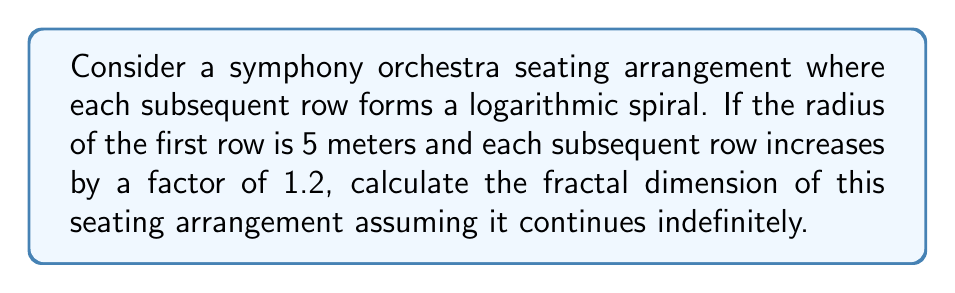Could you help me with this problem? To calculate the fractal dimension of this orchestral seating arrangement, we'll use the box-counting method. Let's approach this step-by-step:

1) In a logarithmic spiral, the distance from the center increases exponentially with each turn. The radius $r$ at angle $\theta$ is given by:

   $$r = ae^{b\theta}$$

   where $a$ is the starting radius and $b$ is the growth factor.

2) In our case, $a = 5$ and the growth factor between rows is 1.2. We can find $b$ using:

   $$e^{2\pi b} = 1.2$$
   $$b = \frac{\ln(1.2)}{2\pi} \approx 0.0291$$

3) The fractal dimension $D$ of a logarithmic spiral is given by:

   $$D = \frac{2}{1 + \sqrt{1 + \frac{1}{b^2}}}$$

4) Substituting our value of $b$:

   $$D = \frac{2}{1 + \sqrt{1 + \frac{1}{0.0291^2}}}$$

5) Simplifying:

   $$D = \frac{2}{1 + \sqrt{1 + 1180.6}} \approx 1.0029$$

This fractal dimension is very close to 1, which is expected for a spiral that doesn't overlap itself significantly.
Answer: $D \approx 1.0029$ 